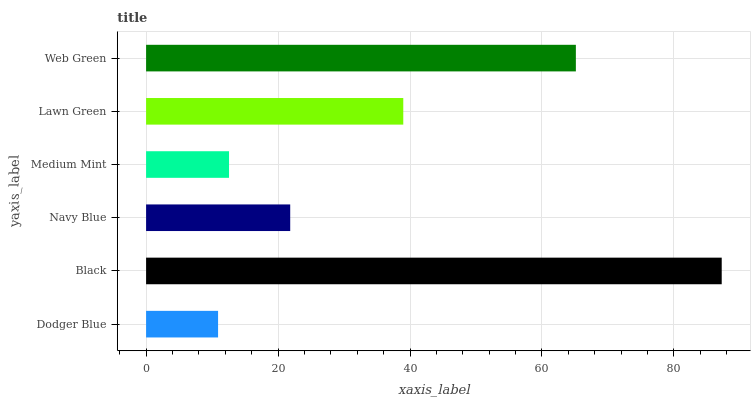Is Dodger Blue the minimum?
Answer yes or no. Yes. Is Black the maximum?
Answer yes or no. Yes. Is Navy Blue the minimum?
Answer yes or no. No. Is Navy Blue the maximum?
Answer yes or no. No. Is Black greater than Navy Blue?
Answer yes or no. Yes. Is Navy Blue less than Black?
Answer yes or no. Yes. Is Navy Blue greater than Black?
Answer yes or no. No. Is Black less than Navy Blue?
Answer yes or no. No. Is Lawn Green the high median?
Answer yes or no. Yes. Is Navy Blue the low median?
Answer yes or no. Yes. Is Black the high median?
Answer yes or no. No. Is Web Green the low median?
Answer yes or no. No. 